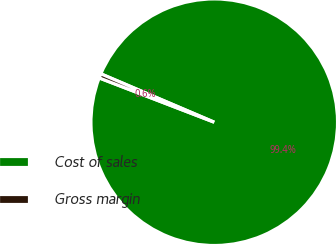Convert chart. <chart><loc_0><loc_0><loc_500><loc_500><pie_chart><fcel>Cost of sales<fcel>Gross margin<nl><fcel>99.43%<fcel>0.57%<nl></chart> 